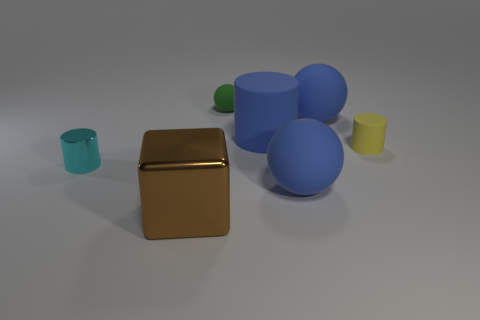The big object that is in front of the tiny cyan metal cylinder and on the right side of the green ball is made of what material?
Your response must be concise. Rubber. What color is the shiny thing right of the tiny cyan object?
Give a very brief answer. Brown. Is the number of small cyan metal things behind the small metal thing greater than the number of big matte things?
Provide a succinct answer. No. How many other things are the same size as the block?
Ensure brevity in your answer.  3. What number of big balls are in front of the green matte sphere?
Provide a succinct answer. 2. Is the number of brown objects that are to the right of the big matte cylinder the same as the number of cyan metallic cylinders that are behind the tiny ball?
Offer a very short reply. Yes. What size is the yellow rubber object that is the same shape as the cyan metallic object?
Provide a succinct answer. Small. There is a yellow thing that is behind the tiny cyan cylinder; what is its shape?
Offer a terse response. Cylinder. Do the blue ball that is behind the small cyan cylinder and the small yellow cylinder in front of the big blue cylinder have the same material?
Keep it short and to the point. Yes. The brown shiny object is what shape?
Give a very brief answer. Cube. 